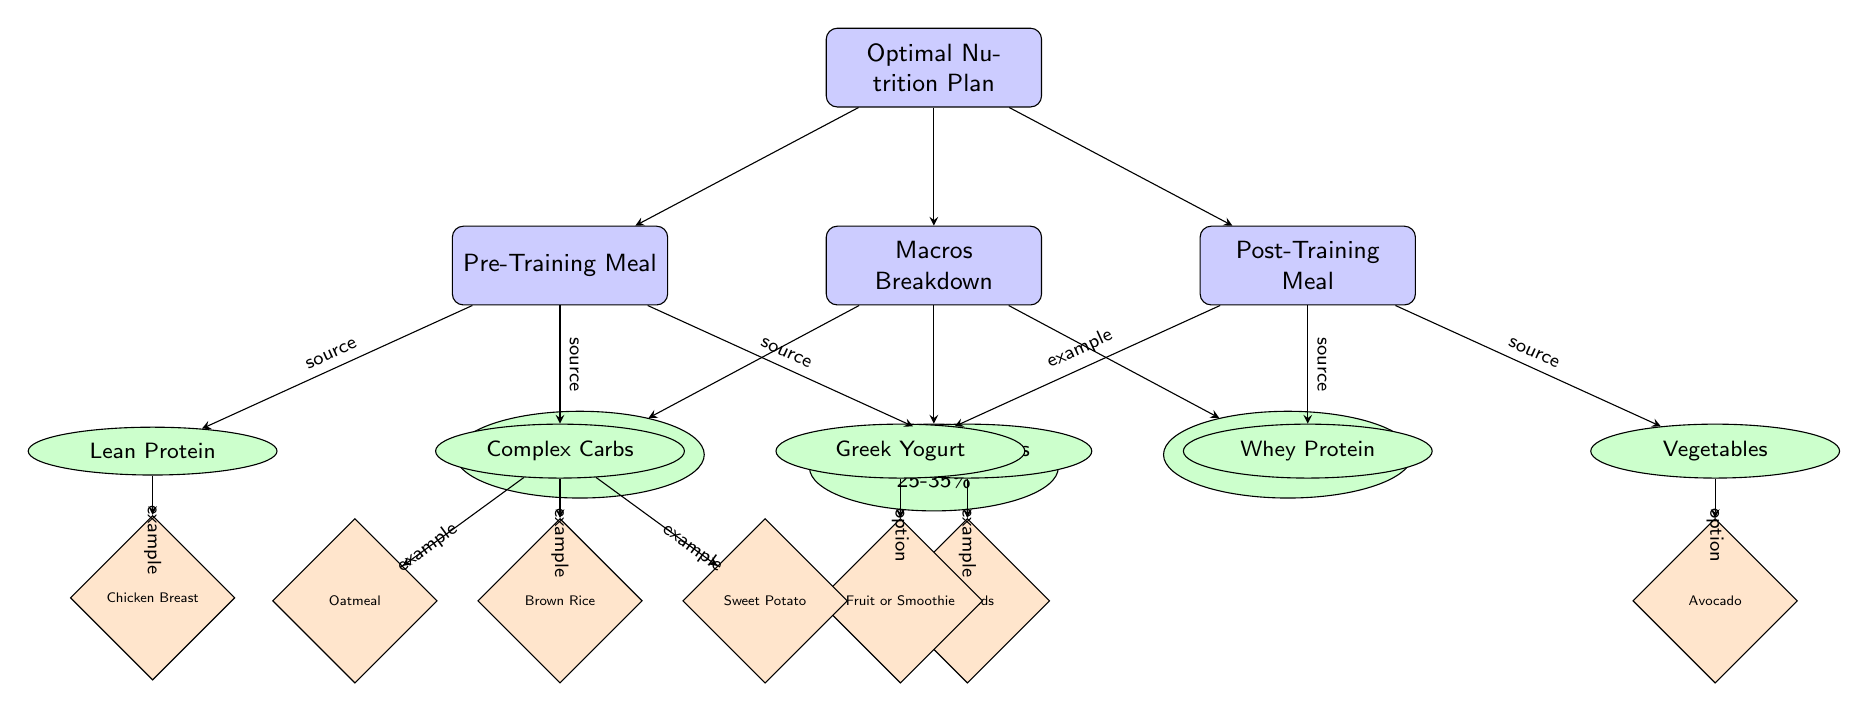What is the percentage range for carbohydrates in the macros breakdown? The diagram indicates that carbohydrates make up 30-50% in the macros breakdown, as seen in the node labeled "Carbohydrates".
Answer: 30-50% How many main nodes are in the diagram? There are four main nodes in the diagram: "Optimal Nutrition Plan", "Macros Breakdown", "Pre-Training Meal", and "Post-Training Meal".
Answer: 4 Which meal includes Greek yogurt? The diagram shows that Greek yogurt is connected to the "Post-Training Meal", indicating that it is included in that meal.
Answer: Post-Training Meal What types of fats are recommended in the pre-training meal? The diagram specifies "Healthy Fats" in the pre-training meal, which is directly linked to that node.
Answer: Healthy Fats What is a complex carbohydrate example listed in the diagram? According to the diagram, "Brown Rice" is provided as an example of a complex carbohydrate, which branches out under the "Complex Carbs" node.
Answer: Brown Rice Which macro category has the highest percentage range? The macro category "Carbohydrates" ranges from 30-50%, while "Proteins" ranges from 25-35% and "Fats" ranges from 20-30%. The carbohydrates have the highest range.
Answer: Carbohydrates What type of protein is directly associated with the pre-training meal? The diagram indicates "Lean Protein" as the type of protein associated with the pre-training meal, placed directly under the "Pre-Training Meal" node.
Answer: Lean Protein Which macro is situated to the right of the protein category? In the diagram, "Fats" is positioned to the right of the "Proteins" node within the macros breakdown section.
Answer: Fats What connections do the "Post-Training Meal" have in terms of examples? The node "Post-Training Meal" connects to "Whey Protein", "Greek Yogurt", and "Vegetables", showing the components of the post-training meal.
Answer: Whey Protein, Greek Yogurt, Vegetables 